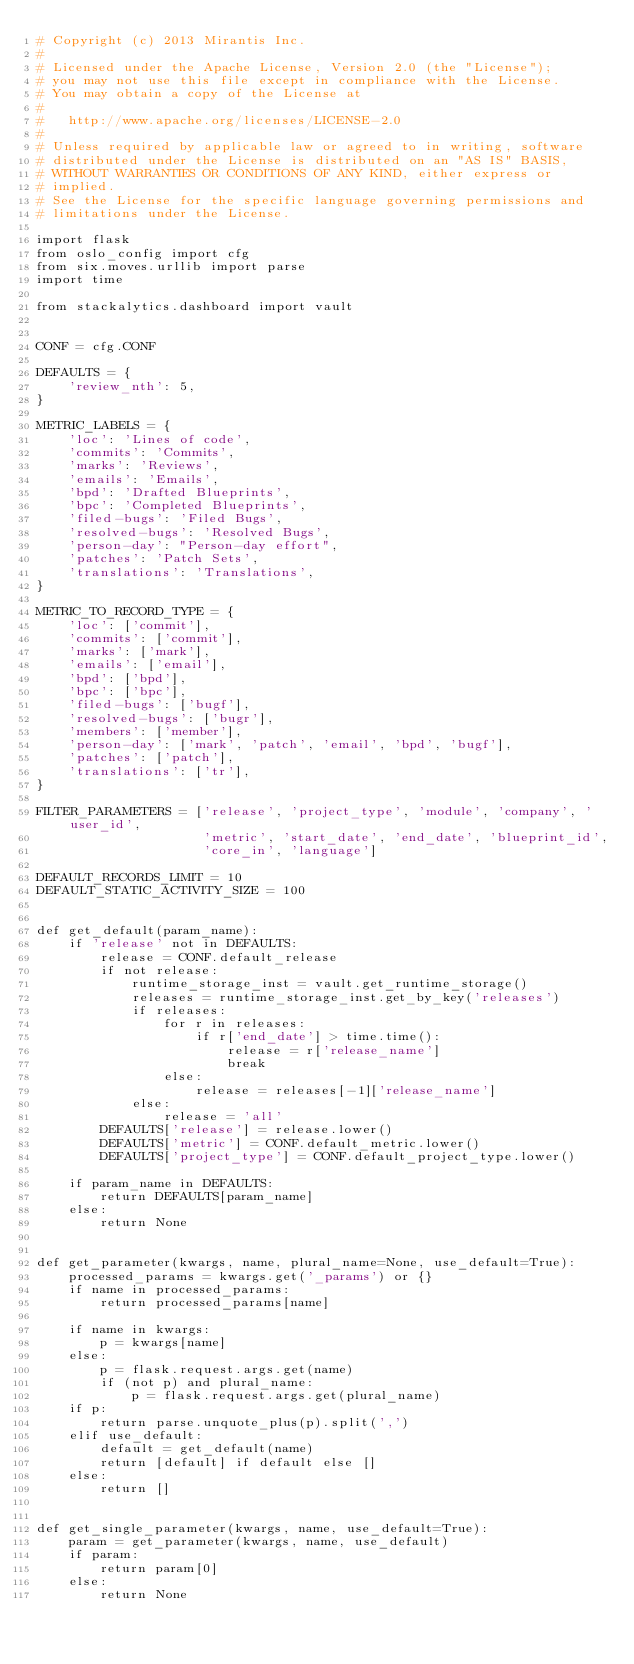Convert code to text. <code><loc_0><loc_0><loc_500><loc_500><_Python_># Copyright (c) 2013 Mirantis Inc.
#
# Licensed under the Apache License, Version 2.0 (the "License");
# you may not use this file except in compliance with the License.
# You may obtain a copy of the License at
#
#   http://www.apache.org/licenses/LICENSE-2.0
#
# Unless required by applicable law or agreed to in writing, software
# distributed under the License is distributed on an "AS IS" BASIS,
# WITHOUT WARRANTIES OR CONDITIONS OF ANY KIND, either express or
# implied.
# See the License for the specific language governing permissions and
# limitations under the License.

import flask
from oslo_config import cfg
from six.moves.urllib import parse
import time

from stackalytics.dashboard import vault


CONF = cfg.CONF

DEFAULTS = {
    'review_nth': 5,
}

METRIC_LABELS = {
    'loc': 'Lines of code',
    'commits': 'Commits',
    'marks': 'Reviews',
    'emails': 'Emails',
    'bpd': 'Drafted Blueprints',
    'bpc': 'Completed Blueprints',
    'filed-bugs': 'Filed Bugs',
    'resolved-bugs': 'Resolved Bugs',
    'person-day': "Person-day effort",
    'patches': 'Patch Sets',
    'translations': 'Translations',
}

METRIC_TO_RECORD_TYPE = {
    'loc': ['commit'],
    'commits': ['commit'],
    'marks': ['mark'],
    'emails': ['email'],
    'bpd': ['bpd'],
    'bpc': ['bpc'],
    'filed-bugs': ['bugf'],
    'resolved-bugs': ['bugr'],
    'members': ['member'],
    'person-day': ['mark', 'patch', 'email', 'bpd', 'bugf'],
    'patches': ['patch'],
    'translations': ['tr'],
}

FILTER_PARAMETERS = ['release', 'project_type', 'module', 'company', 'user_id',
                     'metric', 'start_date', 'end_date', 'blueprint_id',
                     'core_in', 'language']

DEFAULT_RECORDS_LIMIT = 10
DEFAULT_STATIC_ACTIVITY_SIZE = 100


def get_default(param_name):
    if 'release' not in DEFAULTS:
        release = CONF.default_release
        if not release:
            runtime_storage_inst = vault.get_runtime_storage()
            releases = runtime_storage_inst.get_by_key('releases')
            if releases:
                for r in releases:
                    if r['end_date'] > time.time():
                        release = r['release_name']
                        break
                else:
                    release = releases[-1]['release_name']
            else:
                release = 'all'
        DEFAULTS['release'] = release.lower()
        DEFAULTS['metric'] = CONF.default_metric.lower()
        DEFAULTS['project_type'] = CONF.default_project_type.lower()

    if param_name in DEFAULTS:
        return DEFAULTS[param_name]
    else:
        return None


def get_parameter(kwargs, name, plural_name=None, use_default=True):
    processed_params = kwargs.get('_params') or {}
    if name in processed_params:
        return processed_params[name]

    if name in kwargs:
        p = kwargs[name]
    else:
        p = flask.request.args.get(name)
        if (not p) and plural_name:
            p = flask.request.args.get(plural_name)
    if p:
        return parse.unquote_plus(p).split(',')
    elif use_default:
        default = get_default(name)
        return [default] if default else []
    else:
        return []


def get_single_parameter(kwargs, name, use_default=True):
    param = get_parameter(kwargs, name, use_default)
    if param:
        return param[0]
    else:
        return None
</code> 